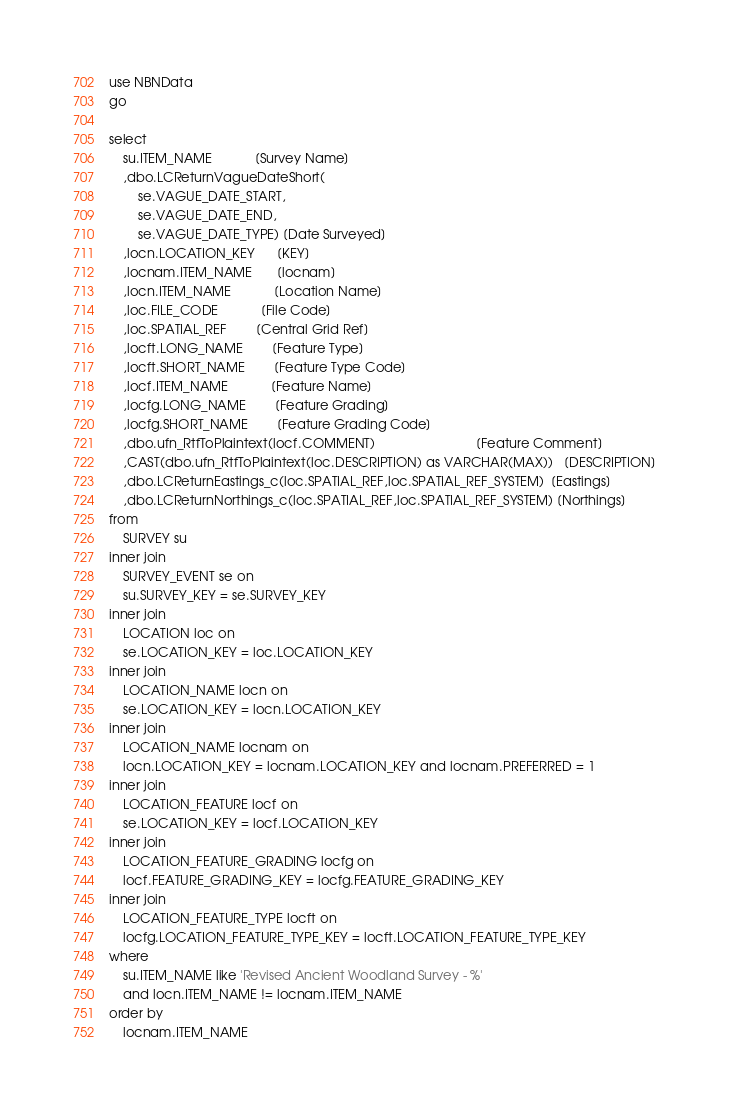Convert code to text. <code><loc_0><loc_0><loc_500><loc_500><_SQL_>use NBNData
go

select
	su.ITEM_NAME			[Survey Name]
	,dbo.LCReturnVagueDateShort(
		se.VAGUE_DATE_START,
		se.VAGUE_DATE_END,
		se.VAGUE_DATE_TYPE) [Date Surveyed]
	,locn.LOCATION_KEY      [KEY]
	,locnam.ITEM_NAME       [locnam]
	,locn.ITEM_NAME			[Location Name]
	,loc.FILE_CODE			[File Code]
	,loc.SPATIAL_REF		[Central Grid Ref]
	,locft.LONG_NAME		[Feature Type]
	,locft.SHORT_NAME		[Feature Type Code]
	,locf.ITEM_NAME			[Feature Name]
	,locfg.LONG_NAME		[Feature Grading]
	,locfg.SHORT_NAME		[Feature Grading Code]
	,dbo.ufn_RtfToPlaintext(locf.COMMENT)                            [Feature Comment]
	,CAST(dbo.ufn_RtfToPlaintext(loc.DESCRIPTION) as VARCHAR(MAX))   [DESCRIPTION]
	,dbo.LCReturnEastings_c(loc.SPATIAL_REF,loc.SPATIAL_REF_SYSTEM)  [Eastings]
	,dbo.LCReturnNorthings_c(loc.SPATIAL_REF,loc.SPATIAL_REF_SYSTEM) [Northings]
from
	SURVEY su
inner join
	SURVEY_EVENT se on
	su.SURVEY_KEY = se.SURVEY_KEY
inner join
	LOCATION loc on
	se.LOCATION_KEY = loc.LOCATION_KEY
inner join
	LOCATION_NAME locn on
	se.LOCATION_KEY = locn.LOCATION_KEY
inner join
	LOCATION_NAME locnam on
	locn.LOCATION_KEY = locnam.LOCATION_KEY and locnam.PREFERRED = 1
inner join
	LOCATION_FEATURE locf on
	se.LOCATION_KEY = locf.LOCATION_KEY
inner join
	LOCATION_FEATURE_GRADING locfg on
	locf.FEATURE_GRADING_KEY = locfg.FEATURE_GRADING_KEY
inner join
	LOCATION_FEATURE_TYPE locft on
	locfg.LOCATION_FEATURE_TYPE_KEY = locft.LOCATION_FEATURE_TYPE_KEY
where
	su.ITEM_NAME like 'Revised Ancient Woodland Survey - %'
	and locn.ITEM_NAME != locnam.ITEM_NAME
order by
	locnam.ITEM_NAME</code> 